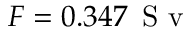<formula> <loc_0><loc_0><loc_500><loc_500>F = 0 . 3 4 7 \, S v</formula> 